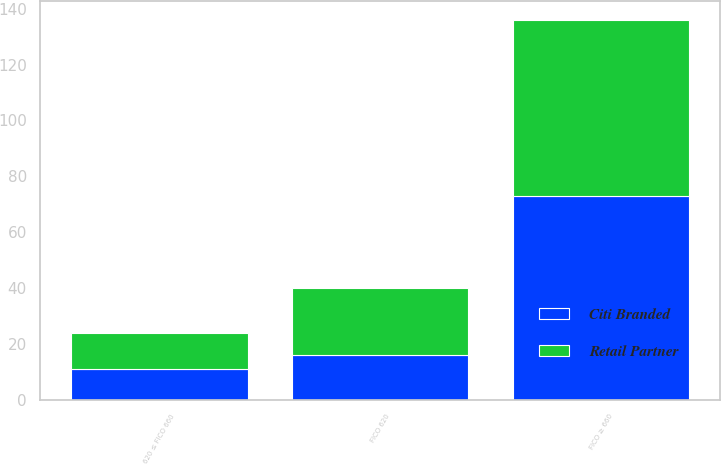Convert chart. <chart><loc_0><loc_0><loc_500><loc_500><stacked_bar_chart><ecel><fcel>FICO ≥ 660<fcel>620 ≤ FICO 660<fcel>FICO 620<nl><fcel>Citi Branded<fcel>73<fcel>11<fcel>16<nl><fcel>Retail Partner<fcel>63<fcel>13<fcel>24<nl></chart> 